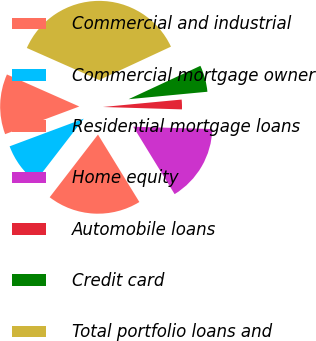Convert chart to OTSL. <chart><loc_0><loc_0><loc_500><loc_500><pie_chart><fcel>Commercial and industrial<fcel>Commercial mortgage owner<fcel>Residential mortgage loans<fcel>Home equity<fcel>Automobile loans<fcel>Credit card<fcel>Total portfolio loans and<nl><fcel>12.32%<fcel>8.87%<fcel>19.21%<fcel>15.76%<fcel>1.98%<fcel>5.43%<fcel>36.44%<nl></chart> 